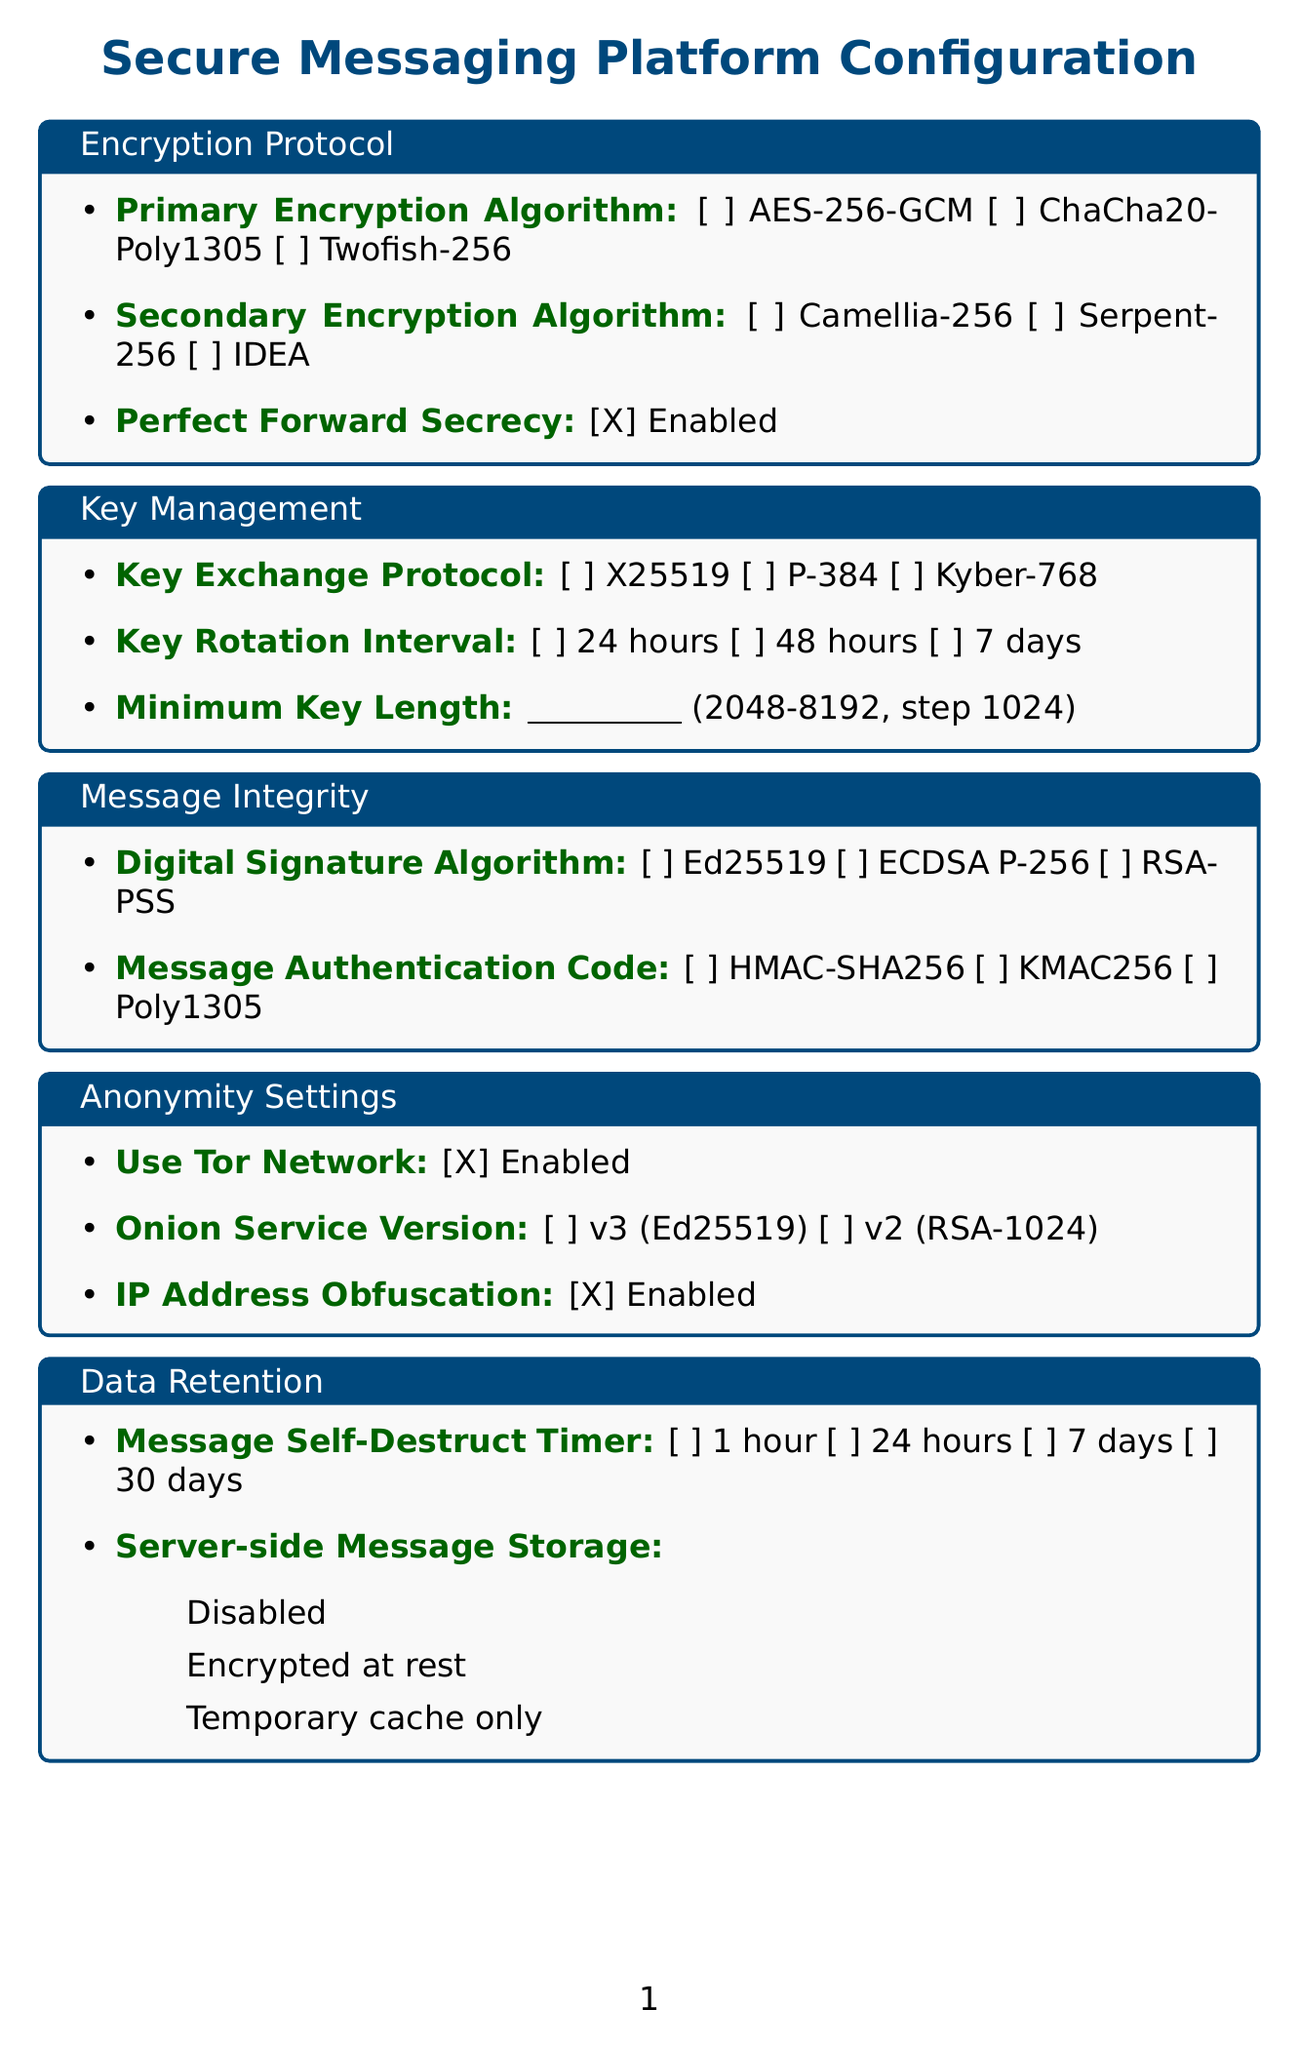What is the title of the form? The title of the form is clearly stated at the top as "Secure Messaging Platform Configuration."
Answer: Secure Messaging Platform Configuration What is the primary encryption algorithm option? The document lists three options for the primary encryption algorithm under the Encryption Protocol section.
Answer: AES-256-GCM What feature is indicated as enabled by default? The document specifies defaults for several fields; one of them is "Perfect Forward Secrecy," which is checked as enabled.
Answer: Enabled How often should key rotation occur according to the options provided? The Key Management section lists three options for key rotation intervals, indicating how frequently keys should be rotated.
Answer: 24 hours What is the maximum key length allowed? The Key Management section specifies a range for "Minimum Key Length," from 2048 to 8192.
Answer: 8192 Which digital signature algorithm is available in the document? The Message Integrity section provides three options, and one of them is specifically mentioned.
Answer: Ed25519 What is the method for two-factor authentication mentioned? The Access Control section outlines the available methods for two-factor authentication.
Answer: TOTP What is the message self-destruct timer option that allows the longest duration? The Data Retention section details the options for the timer, with various durations given therein.
Answer: 30 days Which data retention strategy is mentioned as disabled? The document presents options for server-side message storage, where "Disabled" is one of the choices.
Answer: Disabled 